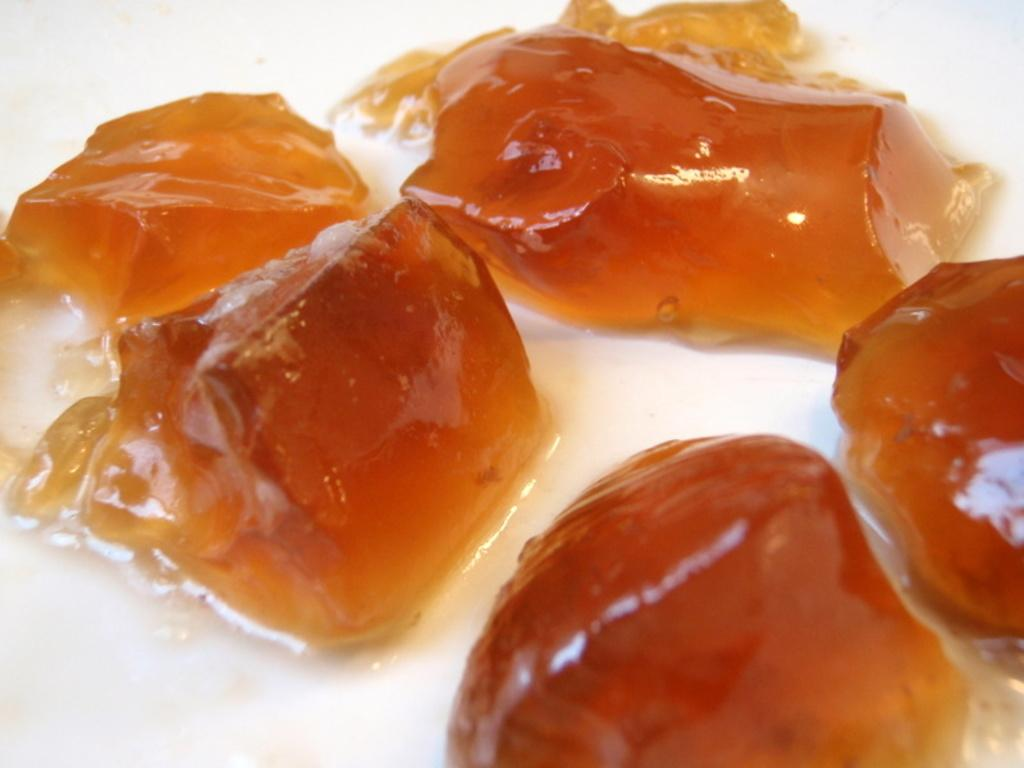What type of items are visible in the image? There are objects in the image that look like food. Can you describe the surface on which the objects are placed? The surface on which the objects are placed is white. What type of pies can be seen in the image? There is no reference to pies in the image, as it only features objects that look like food on a white surface. What is the reason for the objects in the image to be laughing? The objects in the image are not capable of laughing, as they are inanimate objects. 